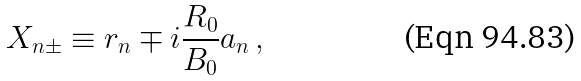<formula> <loc_0><loc_0><loc_500><loc_500>X _ { n \pm } \equiv r _ { n } \mp i \frac { R _ { 0 } } { B _ { 0 } } a _ { n } \, ,</formula> 